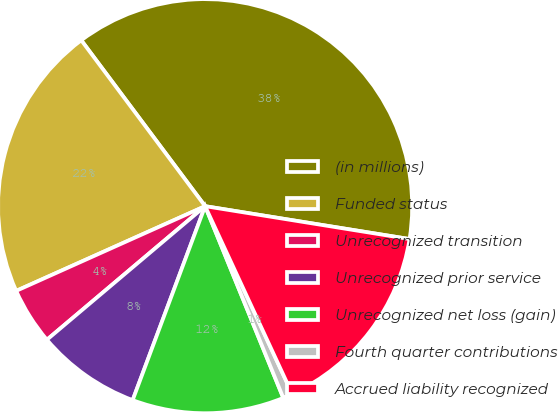Convert chart. <chart><loc_0><loc_0><loc_500><loc_500><pie_chart><fcel>(in millions)<fcel>Funded status<fcel>Unrecognized transition<fcel>Unrecognized prior service<fcel>Unrecognized net loss (gain)<fcel>Fourth quarter contributions<fcel>Accrued liability recognized<nl><fcel>37.74%<fcel>21.5%<fcel>4.45%<fcel>8.15%<fcel>11.85%<fcel>0.75%<fcel>15.55%<nl></chart> 